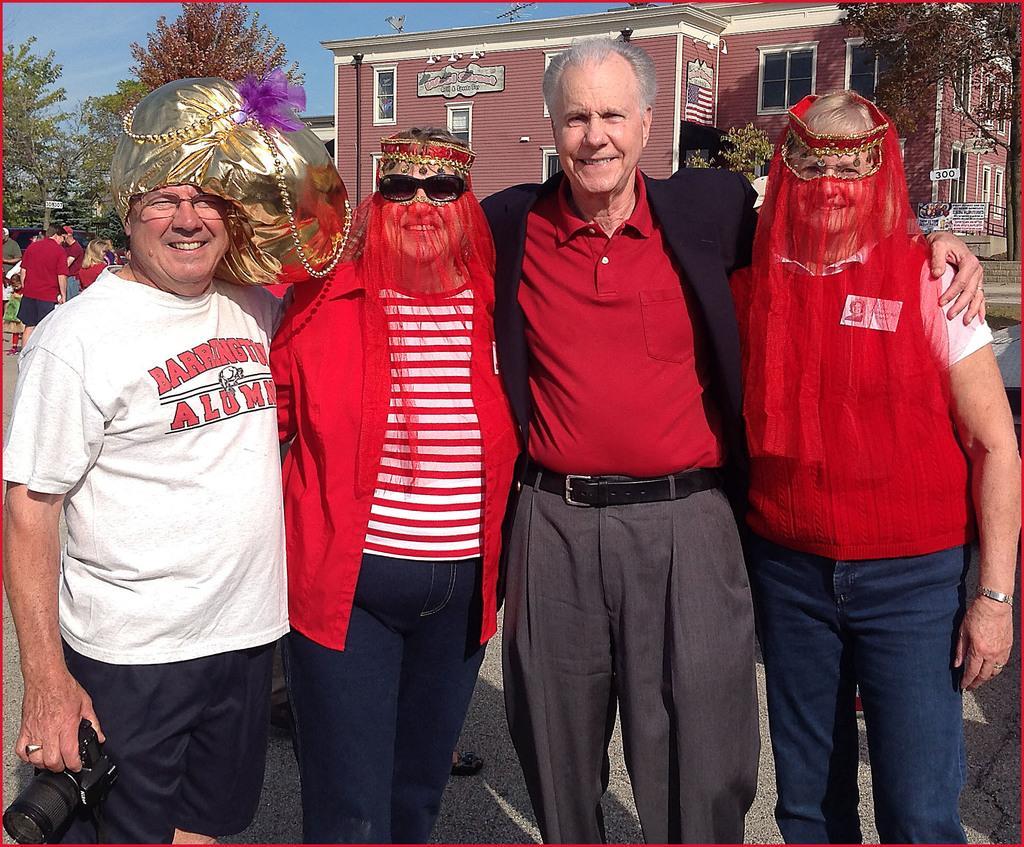In one or two sentences, can you explain what this image depicts? In the picture I can see a group of people are standing on the ground. In the background I can see buildings, trees, the sky and some other objects. 